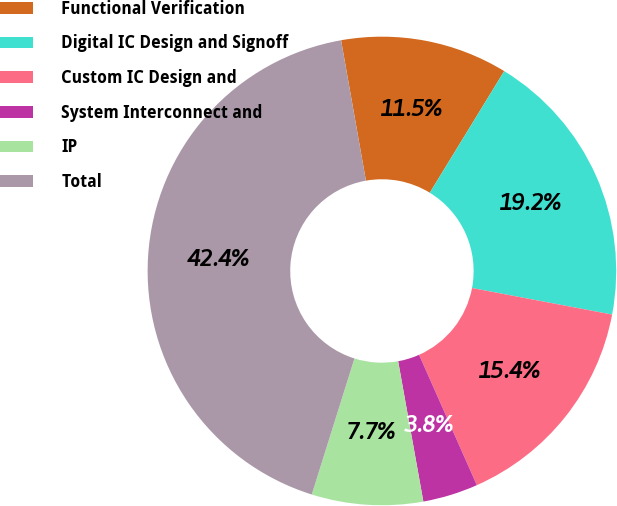Convert chart. <chart><loc_0><loc_0><loc_500><loc_500><pie_chart><fcel>Functional Verification<fcel>Digital IC Design and Signoff<fcel>Custom IC Design and<fcel>System Interconnect and<fcel>IP<fcel>Total<nl><fcel>11.53%<fcel>19.24%<fcel>15.38%<fcel>3.81%<fcel>7.67%<fcel>42.37%<nl></chart> 